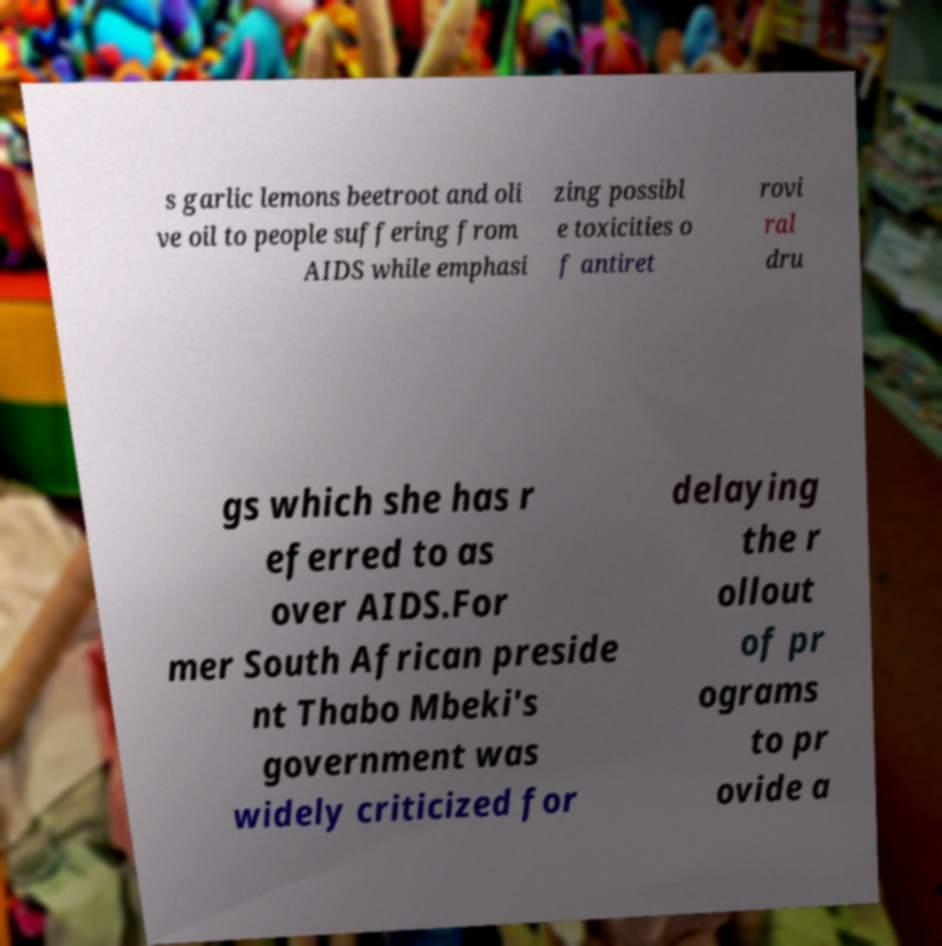Could you assist in decoding the text presented in this image and type it out clearly? s garlic lemons beetroot and oli ve oil to people suffering from AIDS while emphasi zing possibl e toxicities o f antiret rovi ral dru gs which she has r eferred to as over AIDS.For mer South African preside nt Thabo Mbeki's government was widely criticized for delaying the r ollout of pr ograms to pr ovide a 